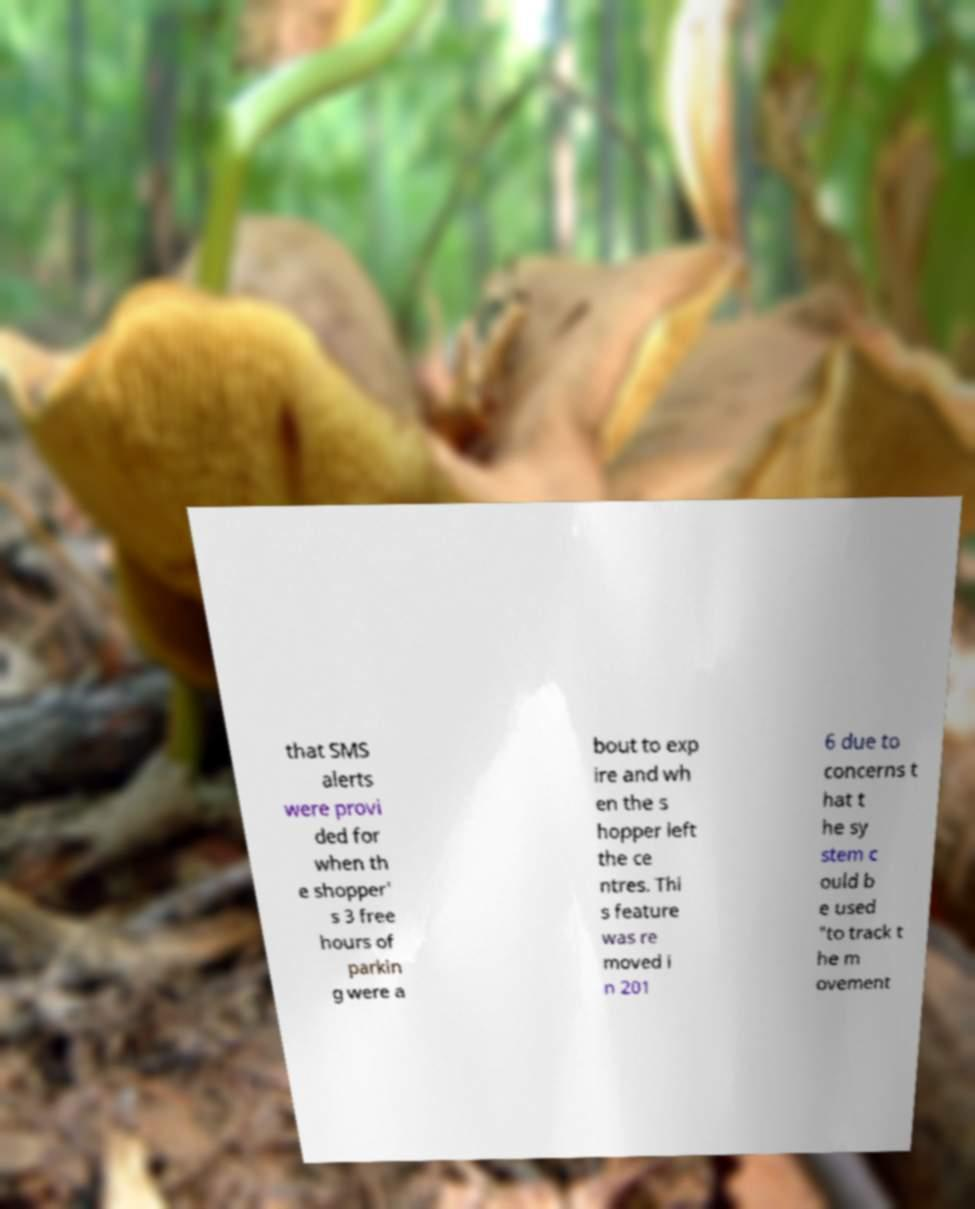What messages or text are displayed in this image? I need them in a readable, typed format. that SMS alerts were provi ded for when th e shopper' s 3 free hours of parkin g were a bout to exp ire and wh en the s hopper left the ce ntres. Thi s feature was re moved i n 201 6 due to concerns t hat t he sy stem c ould b e used "to track t he m ovement 